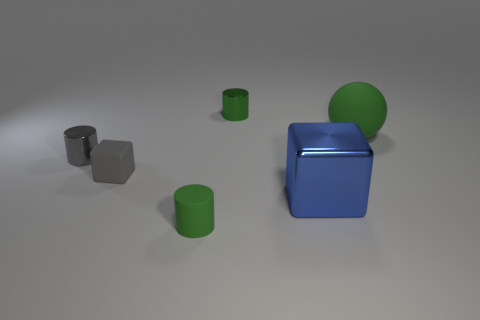Subtract all green cylinders. How many were subtracted if there are1green cylinders left? 1 Add 2 big green things. How many objects exist? 8 Subtract all gray metallic cylinders. How many cylinders are left? 2 Subtract all gray cylinders. How many cylinders are left? 2 Subtract all blocks. How many objects are left? 4 Subtract all purple cubes. Subtract all purple balls. How many cubes are left? 2 Subtract all gray balls. How many cyan cubes are left? 0 Subtract all tiny green metal blocks. Subtract all big balls. How many objects are left? 5 Add 4 tiny rubber things. How many tiny rubber things are left? 6 Add 4 metal cylinders. How many metal cylinders exist? 6 